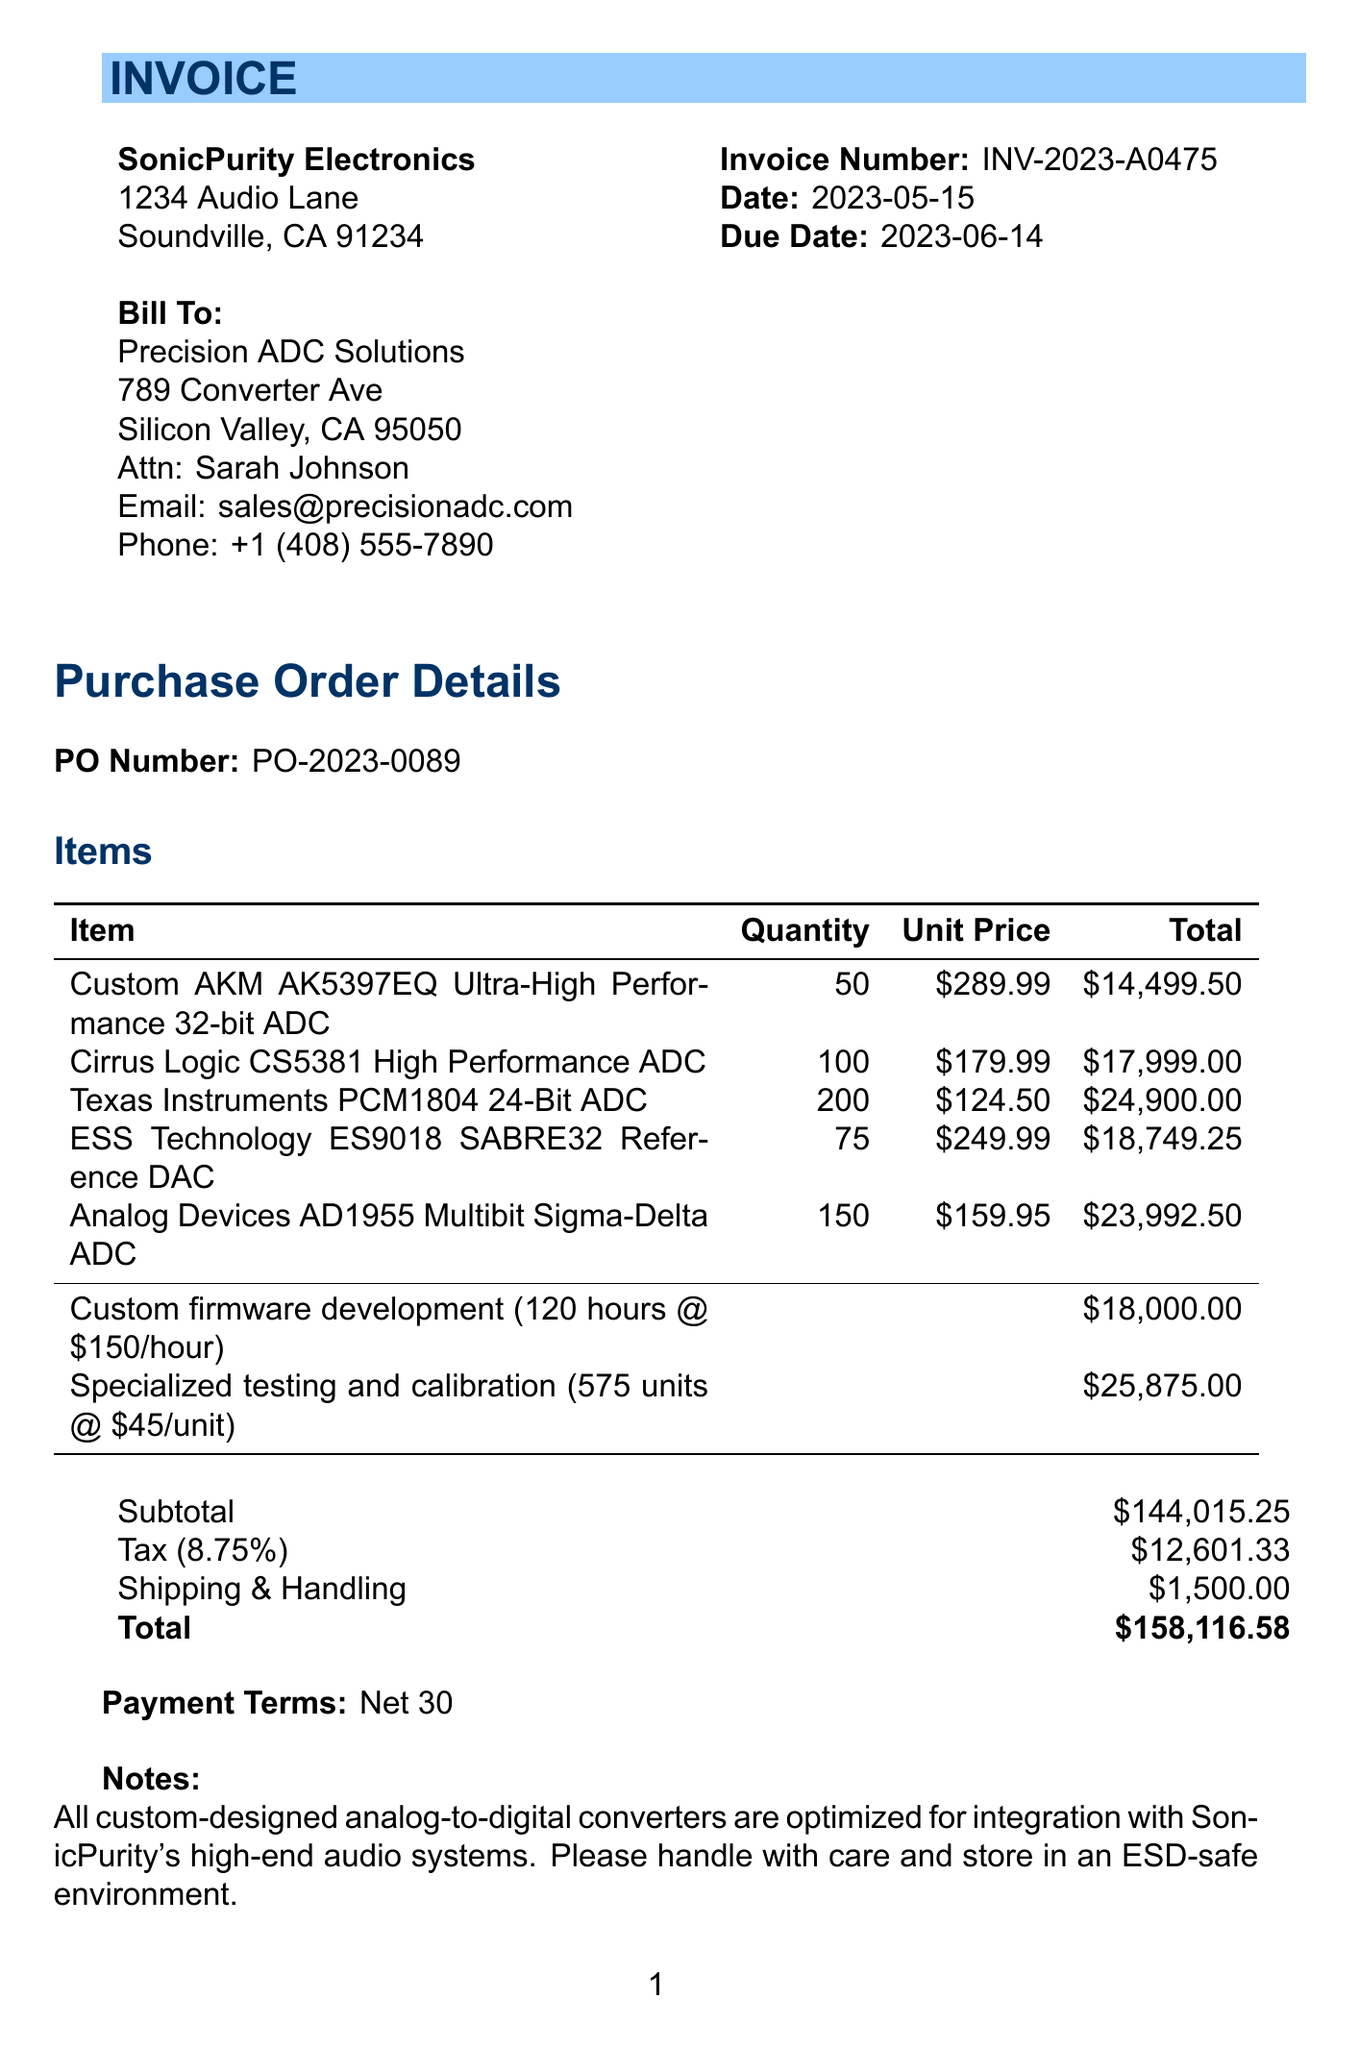what is the invoice number? The invoice number is clearly listed at the top of the document under the invoice details section.
Answer: INV-2023-A0475 what is the due date for payment? The due date is stated in the invoice details section after the date to be paid.
Answer: 2023-06-14 who is the vendor contact person? The contact person for the vendor is mentioned in the vendor details section of the document.
Answer: Sarah Johnson how many units of the Texas Instruments PCM1804 24-Bit ADC are ordered? The quantity of the Texas Instruments PCM1804 24-Bit ADC is provided in the items list section.
Answer: 200 what is the total amount due? The total amount is summarized in the final section of the invoice, summarizing all costs, taxes, and fees.
Answer: $158,116.58 what services are included in the purchase order? The services provided can be found in the additional services section of the document.
Answer: Custom firmware development and specialized testing and calibration what is the tax rate applied? The tax rate can be located in the financial summary area of the document detailing the transaction.
Answer: 8.75% what is the subtotal amount before tax and shipping? The subtotal is clearly stated before the tax and shipping charges in the financial breakdown.
Answer: $144,015.25 